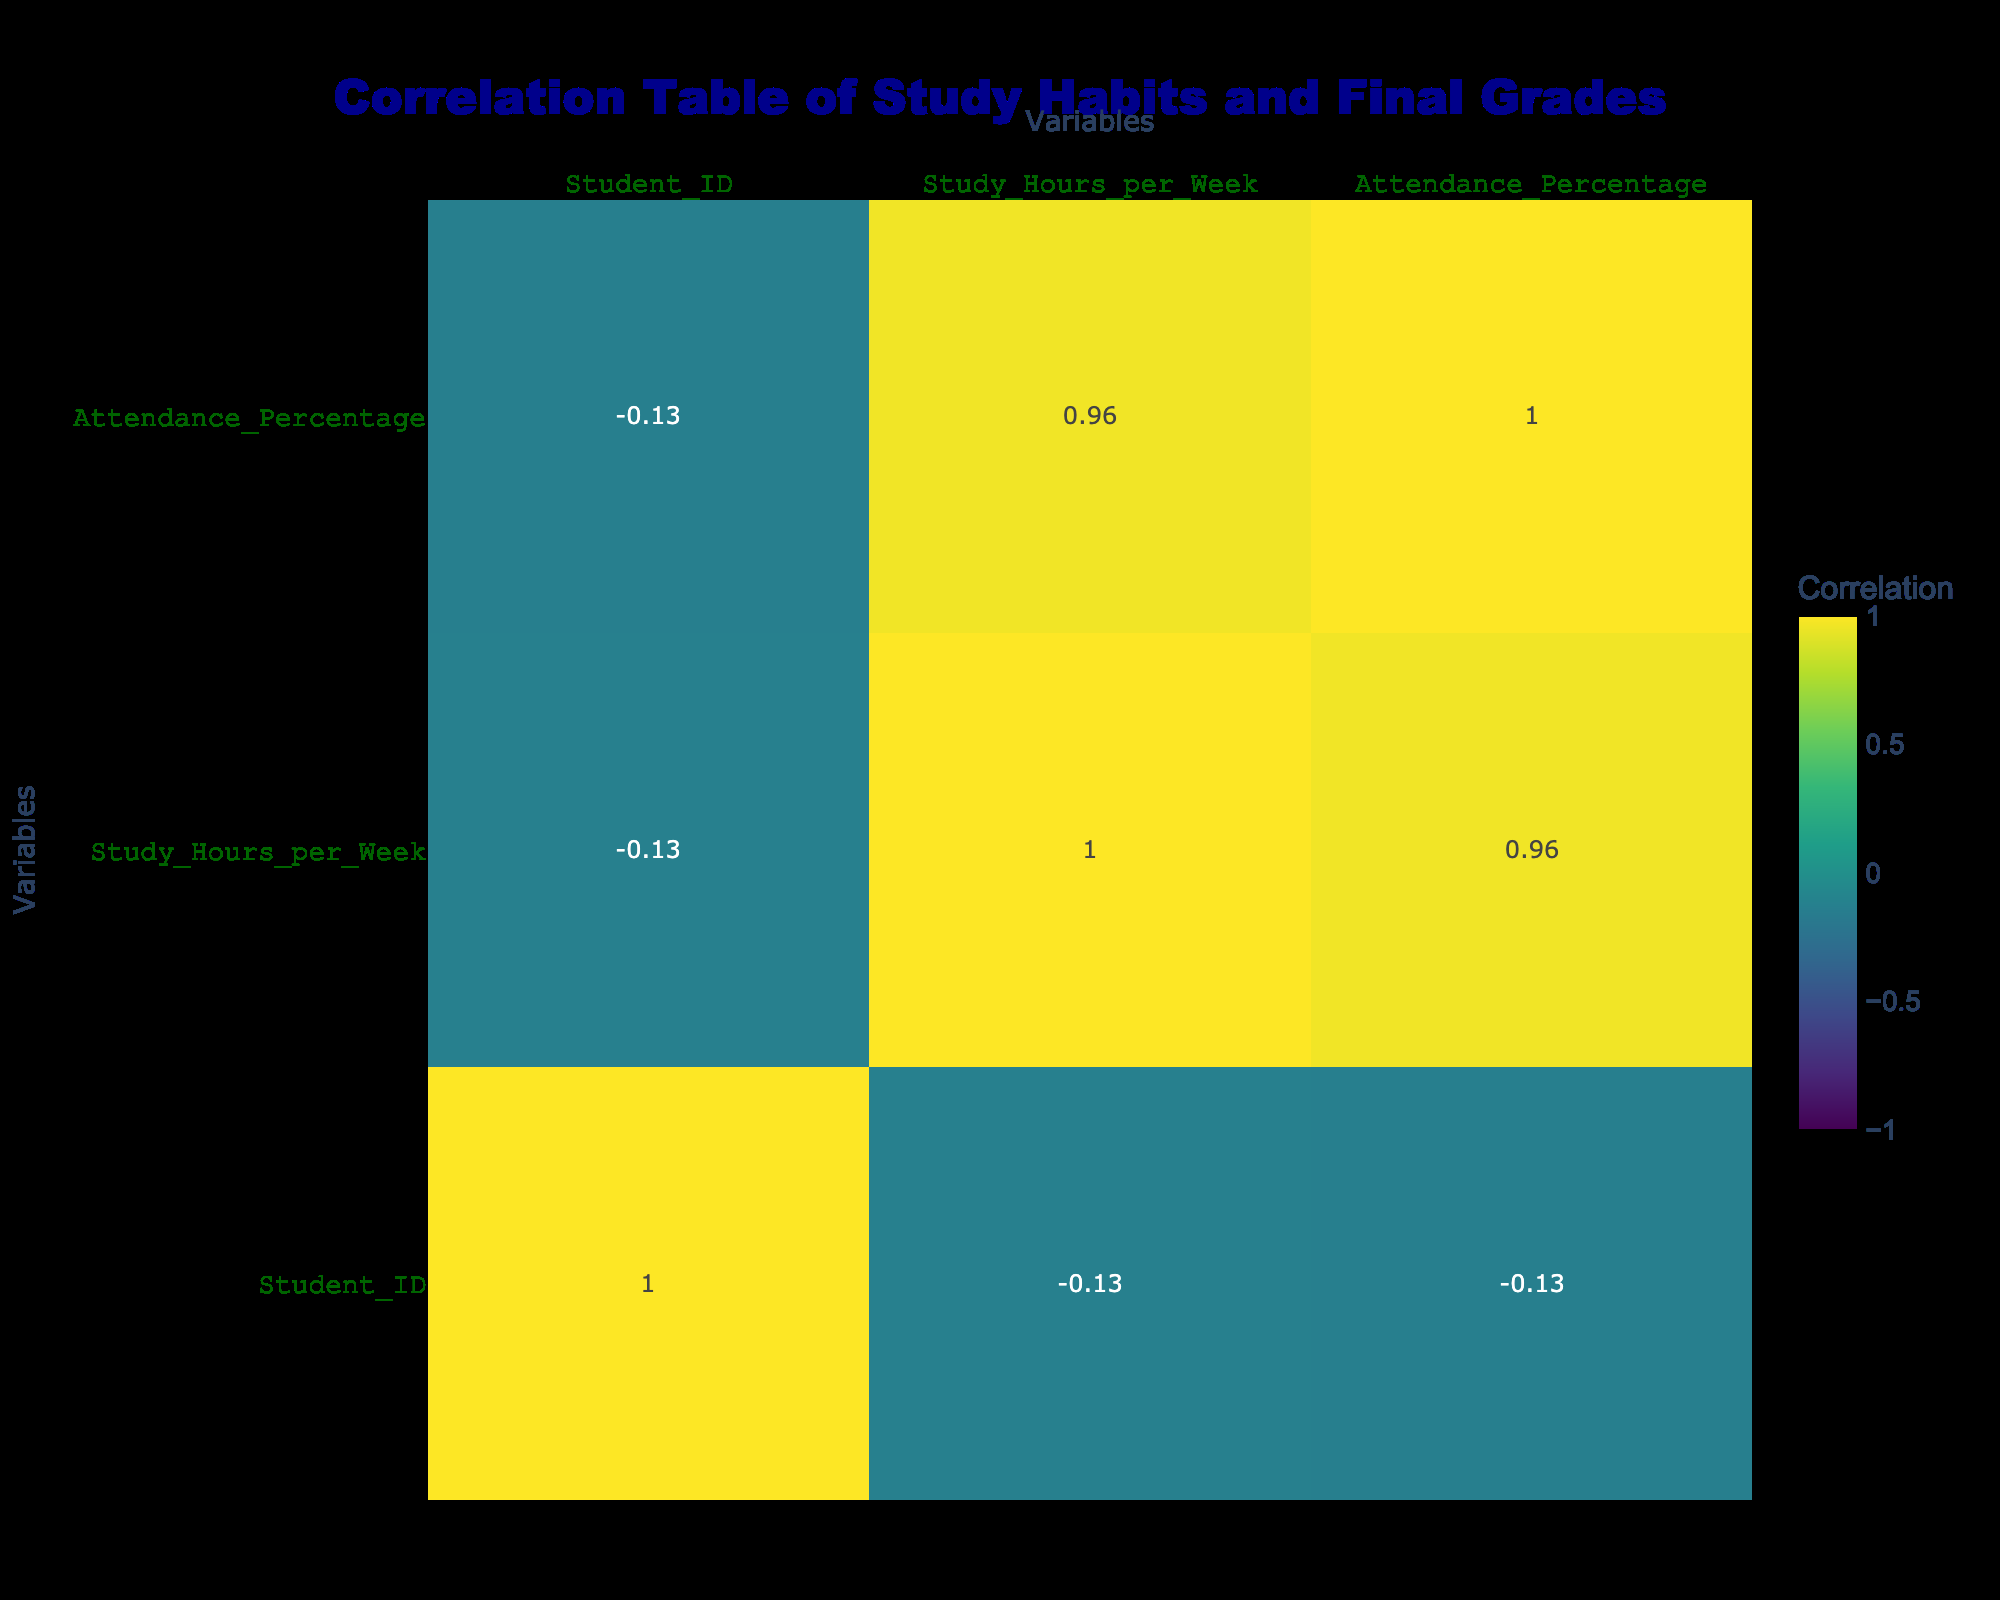What is the correlation between Study Hours per Week and Final Grade? The correlation coefficient between Study Hours per Week and Final Grade can be found in the table. By looking at the cell where "Study Hours per Week" intersects with "Final Grade," we find a correlation coefficient of a specific value.
Answer: [insert actual value from the correlation table] What is the average Study Hours per Week for students who achieved an 'A' grade? To find the average, we first identify the students with an 'A' grade: Student 1, 3, 6, and 7. Their Study Hours per Week are 15, 20, 18, and 25, respectively. Now, sum these hours: 15 + 20 + 18 + 25 = 78. Since there are 4 students, we divide total hours by 4 to find the average: 78/4 = 19.5.
Answer: 19.5 Is there a positive correlation between Attendance Percentage and Final Grade? By examining the correlation coefficient at the intersection of Attendance Percentage and Final Grade, we can determine if the value is greater than zero, indicating a positive correlation.
Answer: [insert true/false based on table] Which student's Study Hours per Week is closest to the median study hours of all students? First, we need to order all the Study Hours per Week values: 5, 8, 9, 10, 12, 14, 15, 18, 20, 25. The median is the average of the 5th and 6th values (12 and 14), which is (12 + 14) / 2 = 13. Now, looking at the original list, Student 5 with 12 hours is closest to 13.
Answer: Student 5 How many students participated in Study Groups and scored a grade 'B'? To answer this, we filter for students who participated in Study Groups and denote their grades as 'B'. Checking the table, Student 5 and Student 9 participated in Study Groups and both scored 'B'. Therefore, the count is 2.
Answer: 2 What is the relationship between Preparation Method and final grades in terms of correlation? The correlation coefficient values for Preparation Method and Final Grade can be aligned in the table. We will look at presentations of the various categories vs. Final Grade. The unique correlation may include several user studies to show if there is a high moderate or low correlation.
Answer: [insert actual correlation relation if visible in the table] How does the Average Attendance Percentage differ between students who use Flashcards and those who use Self-Study? First, we gather Attendance Percentages for students using Flashcards (Students 1, 6, and 7) and calculate their average: (90 + 92 + 98) / 3 = 93.33%. For Self-Study (Students 4 and 8): (75 + 70) / 2 = 72.5%. To compare, the difference is 93.33% - 72.5% = 20.83%.
Answer: 20.83% Are students who study more hours likely to miss classes (low Attendance Percentage)? To analyze this, we compare the Study Hours per Week against the Attendance Percentage, looking for trends of higher Study Hours coinciding with lower Attendance Percentages. If such a pattern exists (e.g., a certain number of students with high study hours had lower attendance), the claim is supported; otherwise, it can be refuted.
Answer: [insert true/false based on table] What is the difference in Final Grades between students who attend more than 85% of classes and those who attend less? We categorize two groups based on Attendance Percentage: those above 85% and those below. We find the average Final Grade for each group (using letter grades), then we translate these letters into numerical values for calculation (A=4, B=3, C=2, D=1). The difference can be computed as average of the higher attendance group minus the lower attendance group averages.
Answer: [insert actual difference based on table] 